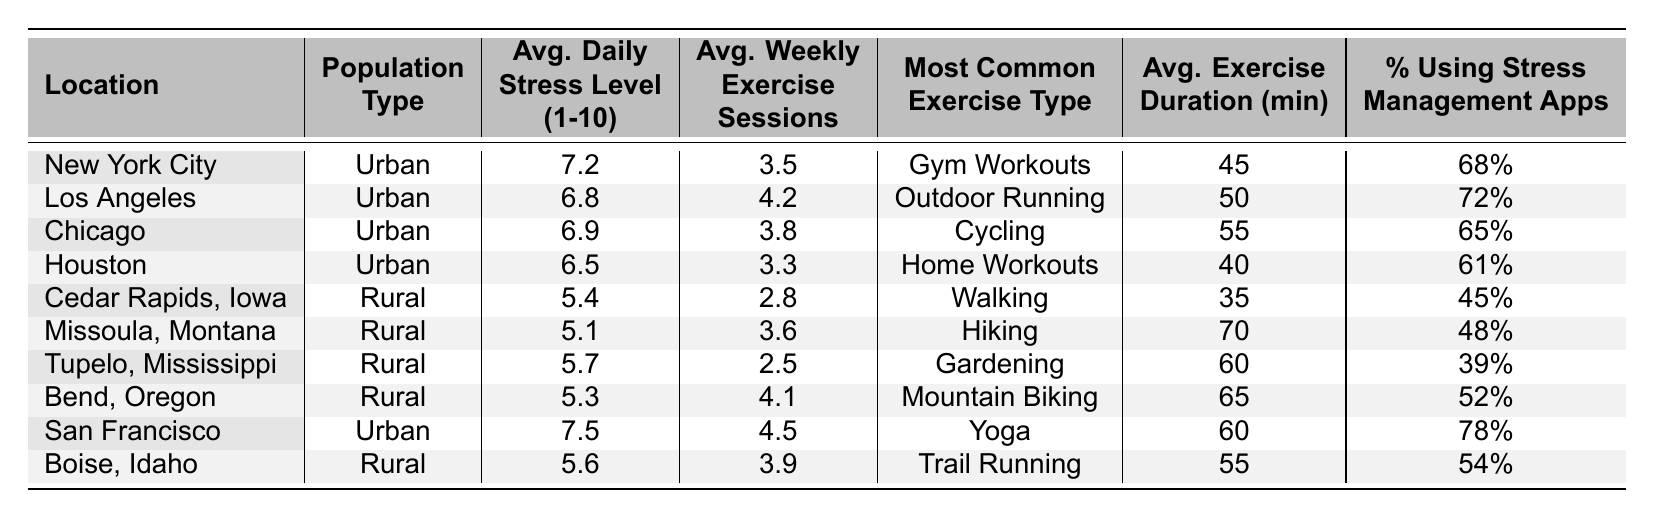What is the average daily stress level for urban populations? The table lists four urban locations with the following average daily stress levels: 7.2, 6.8, 6.9, and 6.5. To find the average, sum these values: 7.2 + 6.8 + 6.9 + 6.5 = 27.4. Then, divide by the number of locations: 27.4 / 4 = 6.85.
Answer: 6.85 Which rural location has the highest average weekly exercise sessions? The table shows the average weekly exercise sessions for the rural locations as follows: Cedar Rapids (2.8), Missoula (3.6), Tupelo (2.5), Bend (4.1), and Boise (3.9). The highest value is 4.1 from Bend.
Answer: Bend, Oregon Is the most common exercise type for urban populations more varied than for rural populations? In urban areas, the most common exercise types are Gym Workouts, Outdoor Running, Cycling, and Home Workouts, totaling four different types. In rural areas, the types are Walking, Hiking, Gardening, Mountain Biking, and Trail Running, totaling five. Since rural has more types, the statement is false.
Answer: No What is the total percentage of urban populations using stress management apps? The table shows the percentages for urban locations: 68%, 72%, 65%, and 61%. To find the total, sum these values: 68 + 72 + 65 + 61 = 266%. To find the average, divide by the number of urban locations: 266 / 4 = 66.5%.
Answer: 66.5% What is the difference in average daily stress levels between urban and rural populations? The average daily stress level for urban populations is 6.85, and for rural populations, it is calculated as follows: 5.4, 5.1, 5.7, 5.3, and 5.6. Their sum is 27.1, dividing gives an average of 27.1 / 5 = 5.42. The difference is 6.85 - 5.42 = 1.43.
Answer: 1.43 Which urban location has the highest average exercise duration? The table lists the average exercise durations for urban locations as: 45, 50, 55, and 40 minutes. The highest value is 55 minutes from Chicago.
Answer: Chicago Is the average weekly exercise sessions higher for rural or urban populations? For urban populations, the average weekly exercise sessions are (3.5 + 4.2 + 3.8 + 3.3) / 4 = 3.775. For rural populations, the average is (2.8 + 3.6 + 2.5 + 4.1 + 3.9) / 5 = 3.42. Comparing both averages (3.775 > 3.42), urban populations have higher sessions on average.
Answer: Yes Which rural location has the lowest average daily stress level? The daily stress levels for rural locations are 5.4, 5.1, 5.7, 5.3, and 5.6. The lowest value is 5.1 from Missoula.
Answer: Missoula, Montana What percentage of people in Los Angeles use stress management apps? The table indicates that in Los Angeles, 72% of the population uses stress management apps.
Answer: 72% What is the average exercise duration for all urban locations combined? The average exercise durations are 45, 50, 55, and 40 minutes. Their total is 45 + 50 + 55 + 40 = 190. Dividing by the number of locations gives 190 / 4 = 47.5 minutes.
Answer: 47.5 minutes Do rural populations engage in more exercise variety than urban populations? Urban populations have four distinct types of exercises listed, while rural populations have five different types. Thus, rural has more variety in exercise options.
Answer: Yes 